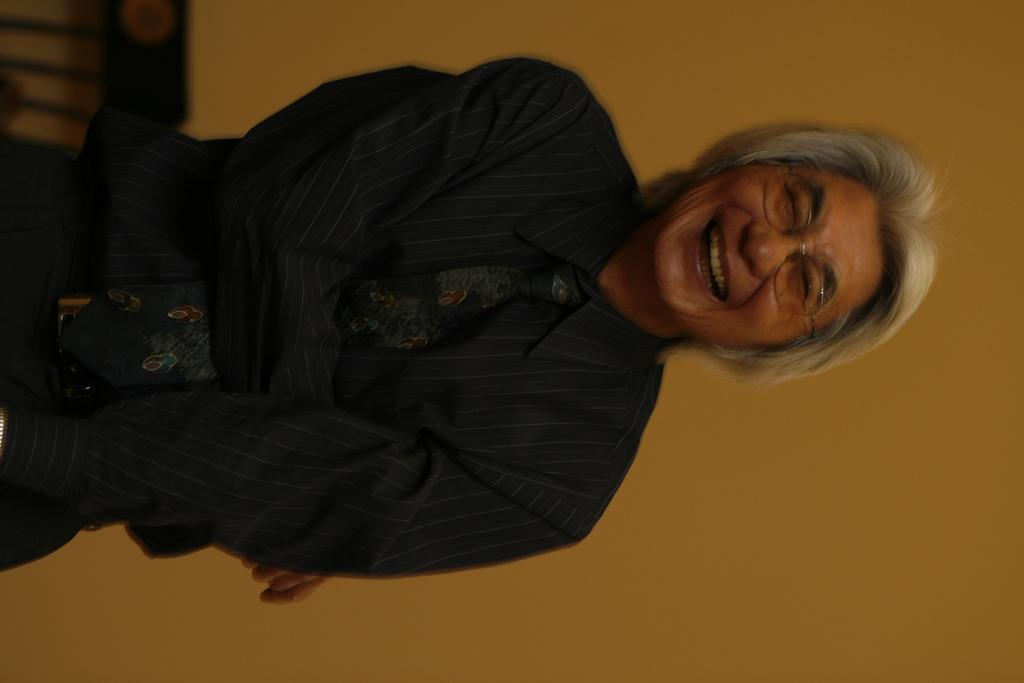Who or what is the main subject in the image? There is a person in the image. What is the person doing in the image? The person is standing. Can you describe any accessories the person is wearing? The person is wearing spectacles. What is the person's facial expression in the image? The person is smiling. What year is depicted in the image? There is no specific year depicted in the image; it is a photograph of a person. Can you see a hose in the image? There is no hose present in the image. 